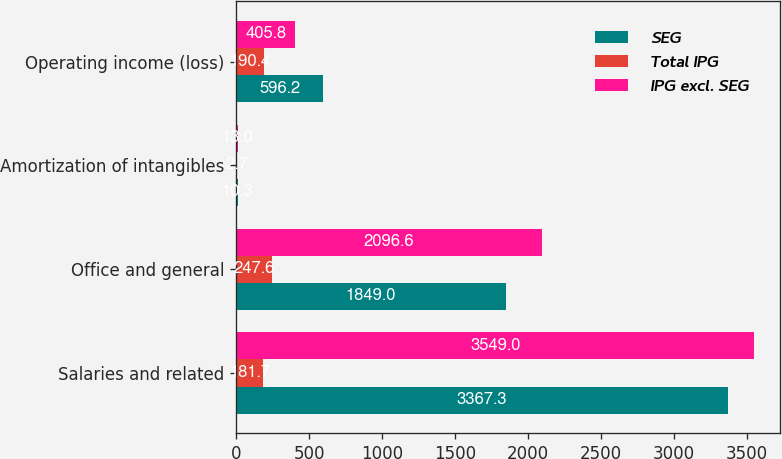Convert chart to OTSL. <chart><loc_0><loc_0><loc_500><loc_500><stacked_bar_chart><ecel><fcel>Salaries and related<fcel>Office and general<fcel>Amortization of intangibles<fcel>Operating income (loss)<nl><fcel>SEG<fcel>3367.3<fcel>1849<fcel>10.3<fcel>596.2<nl><fcel>Total IPG<fcel>181.7<fcel>247.6<fcel>2.7<fcel>190.4<nl><fcel>IPG excl. SEG<fcel>3549<fcel>2096.6<fcel>13<fcel>405.8<nl></chart> 